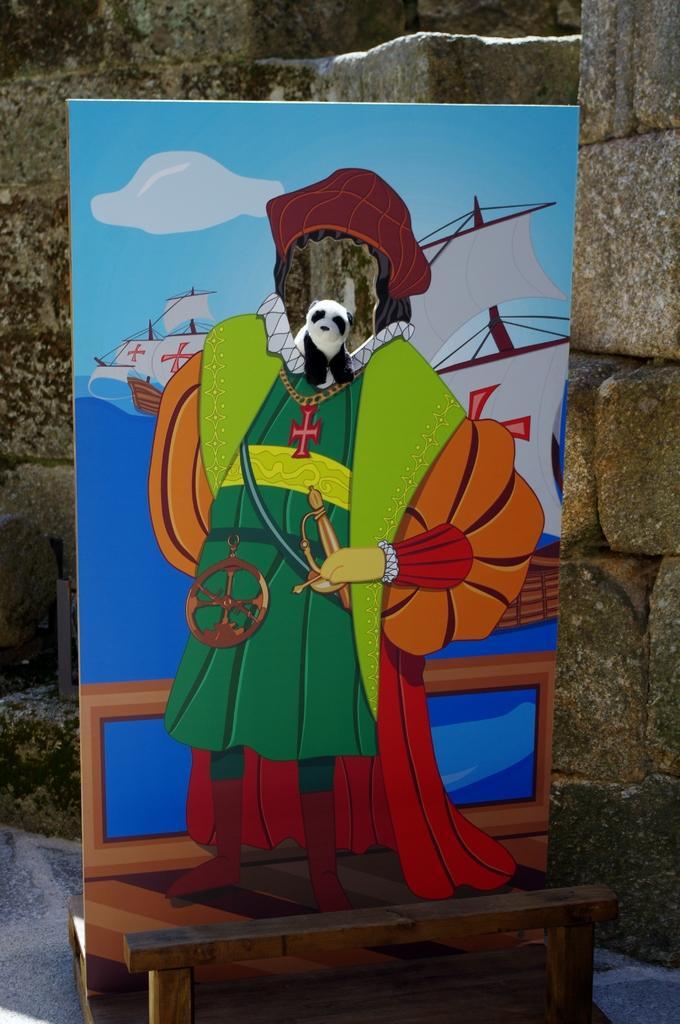Describe this image in one or two sentences. In the middle of the image we can see a banner. Behind the banner there is wall. 